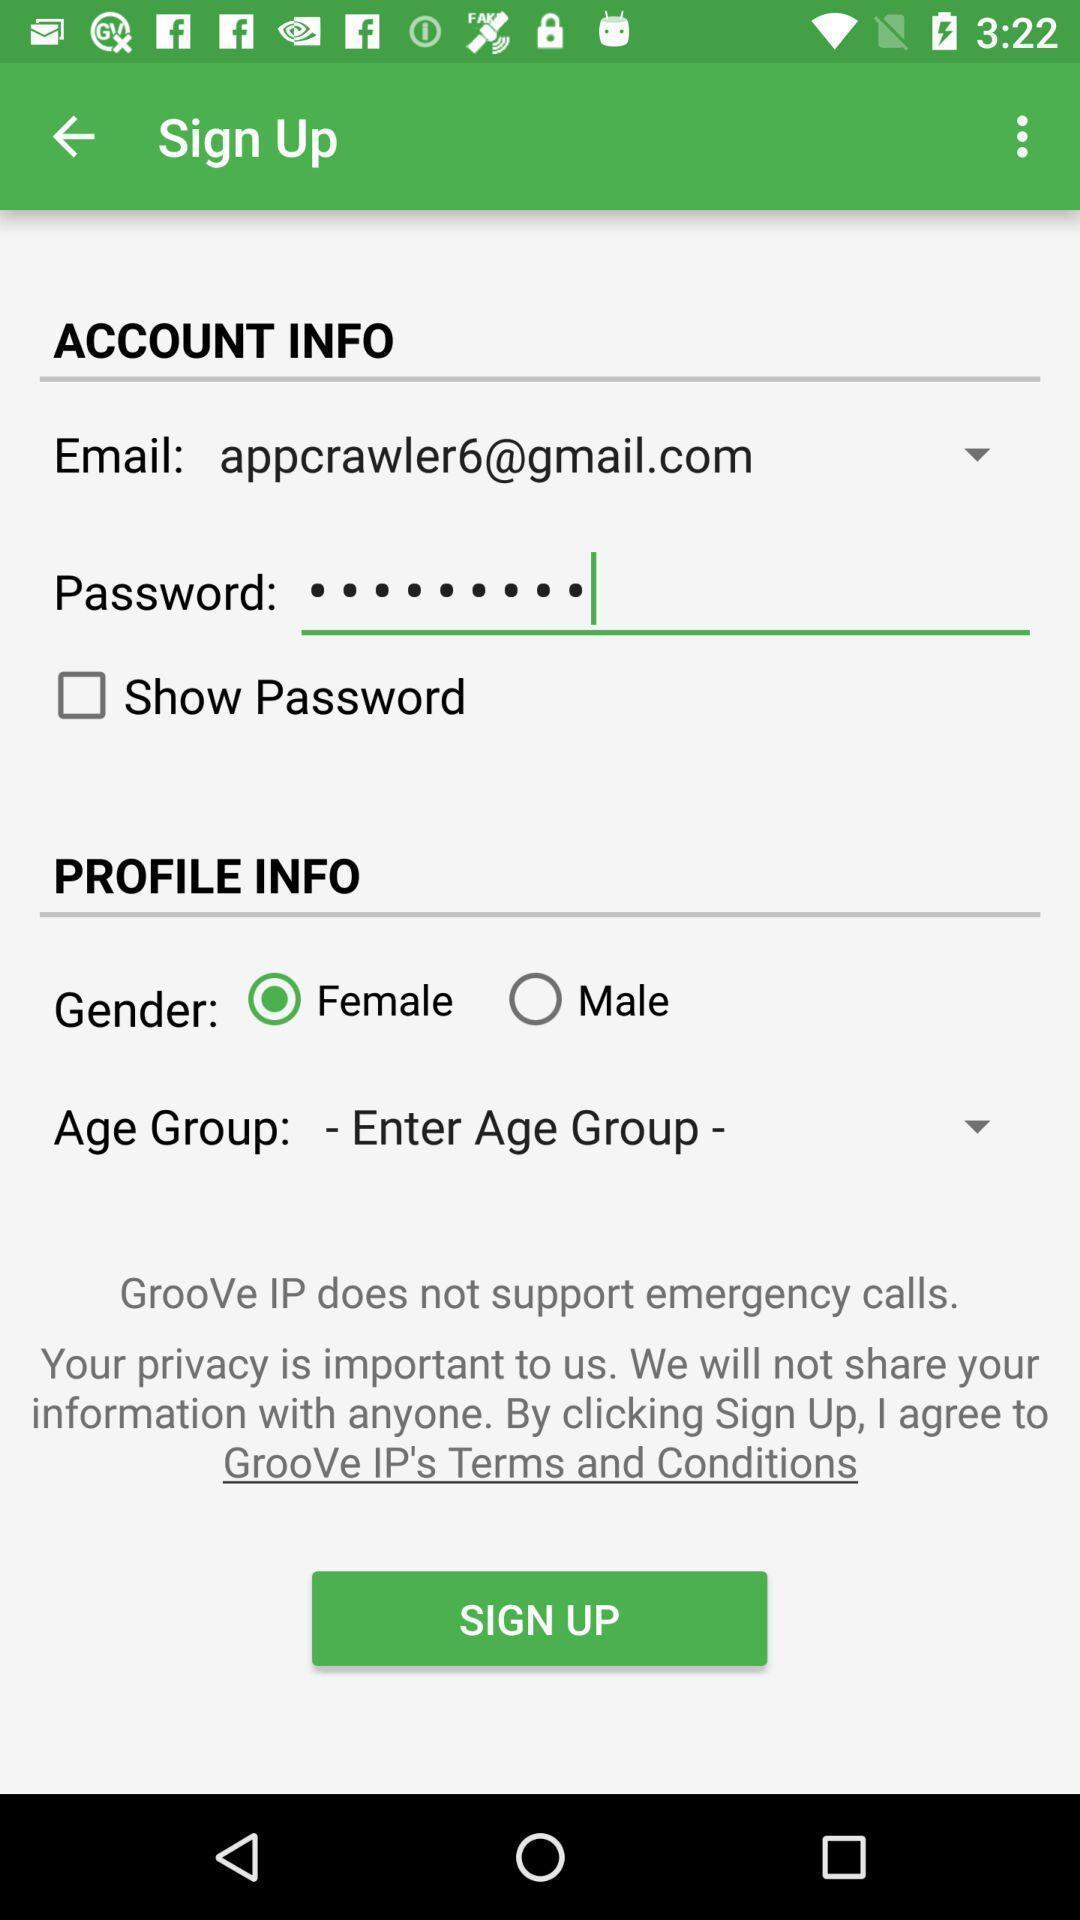Give me a summary of this screen capture. Sign up page for an application. 